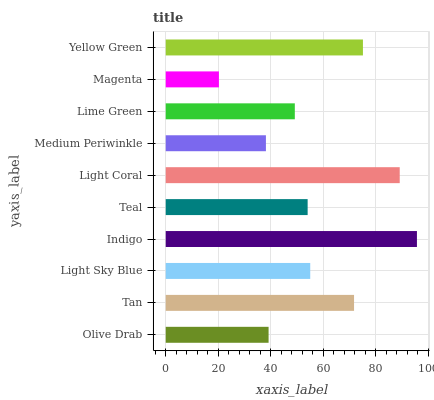Is Magenta the minimum?
Answer yes or no. Yes. Is Indigo the maximum?
Answer yes or no. Yes. Is Tan the minimum?
Answer yes or no. No. Is Tan the maximum?
Answer yes or no. No. Is Tan greater than Olive Drab?
Answer yes or no. Yes. Is Olive Drab less than Tan?
Answer yes or no. Yes. Is Olive Drab greater than Tan?
Answer yes or no. No. Is Tan less than Olive Drab?
Answer yes or no. No. Is Light Sky Blue the high median?
Answer yes or no. Yes. Is Teal the low median?
Answer yes or no. Yes. Is Teal the high median?
Answer yes or no. No. Is Medium Periwinkle the low median?
Answer yes or no. No. 